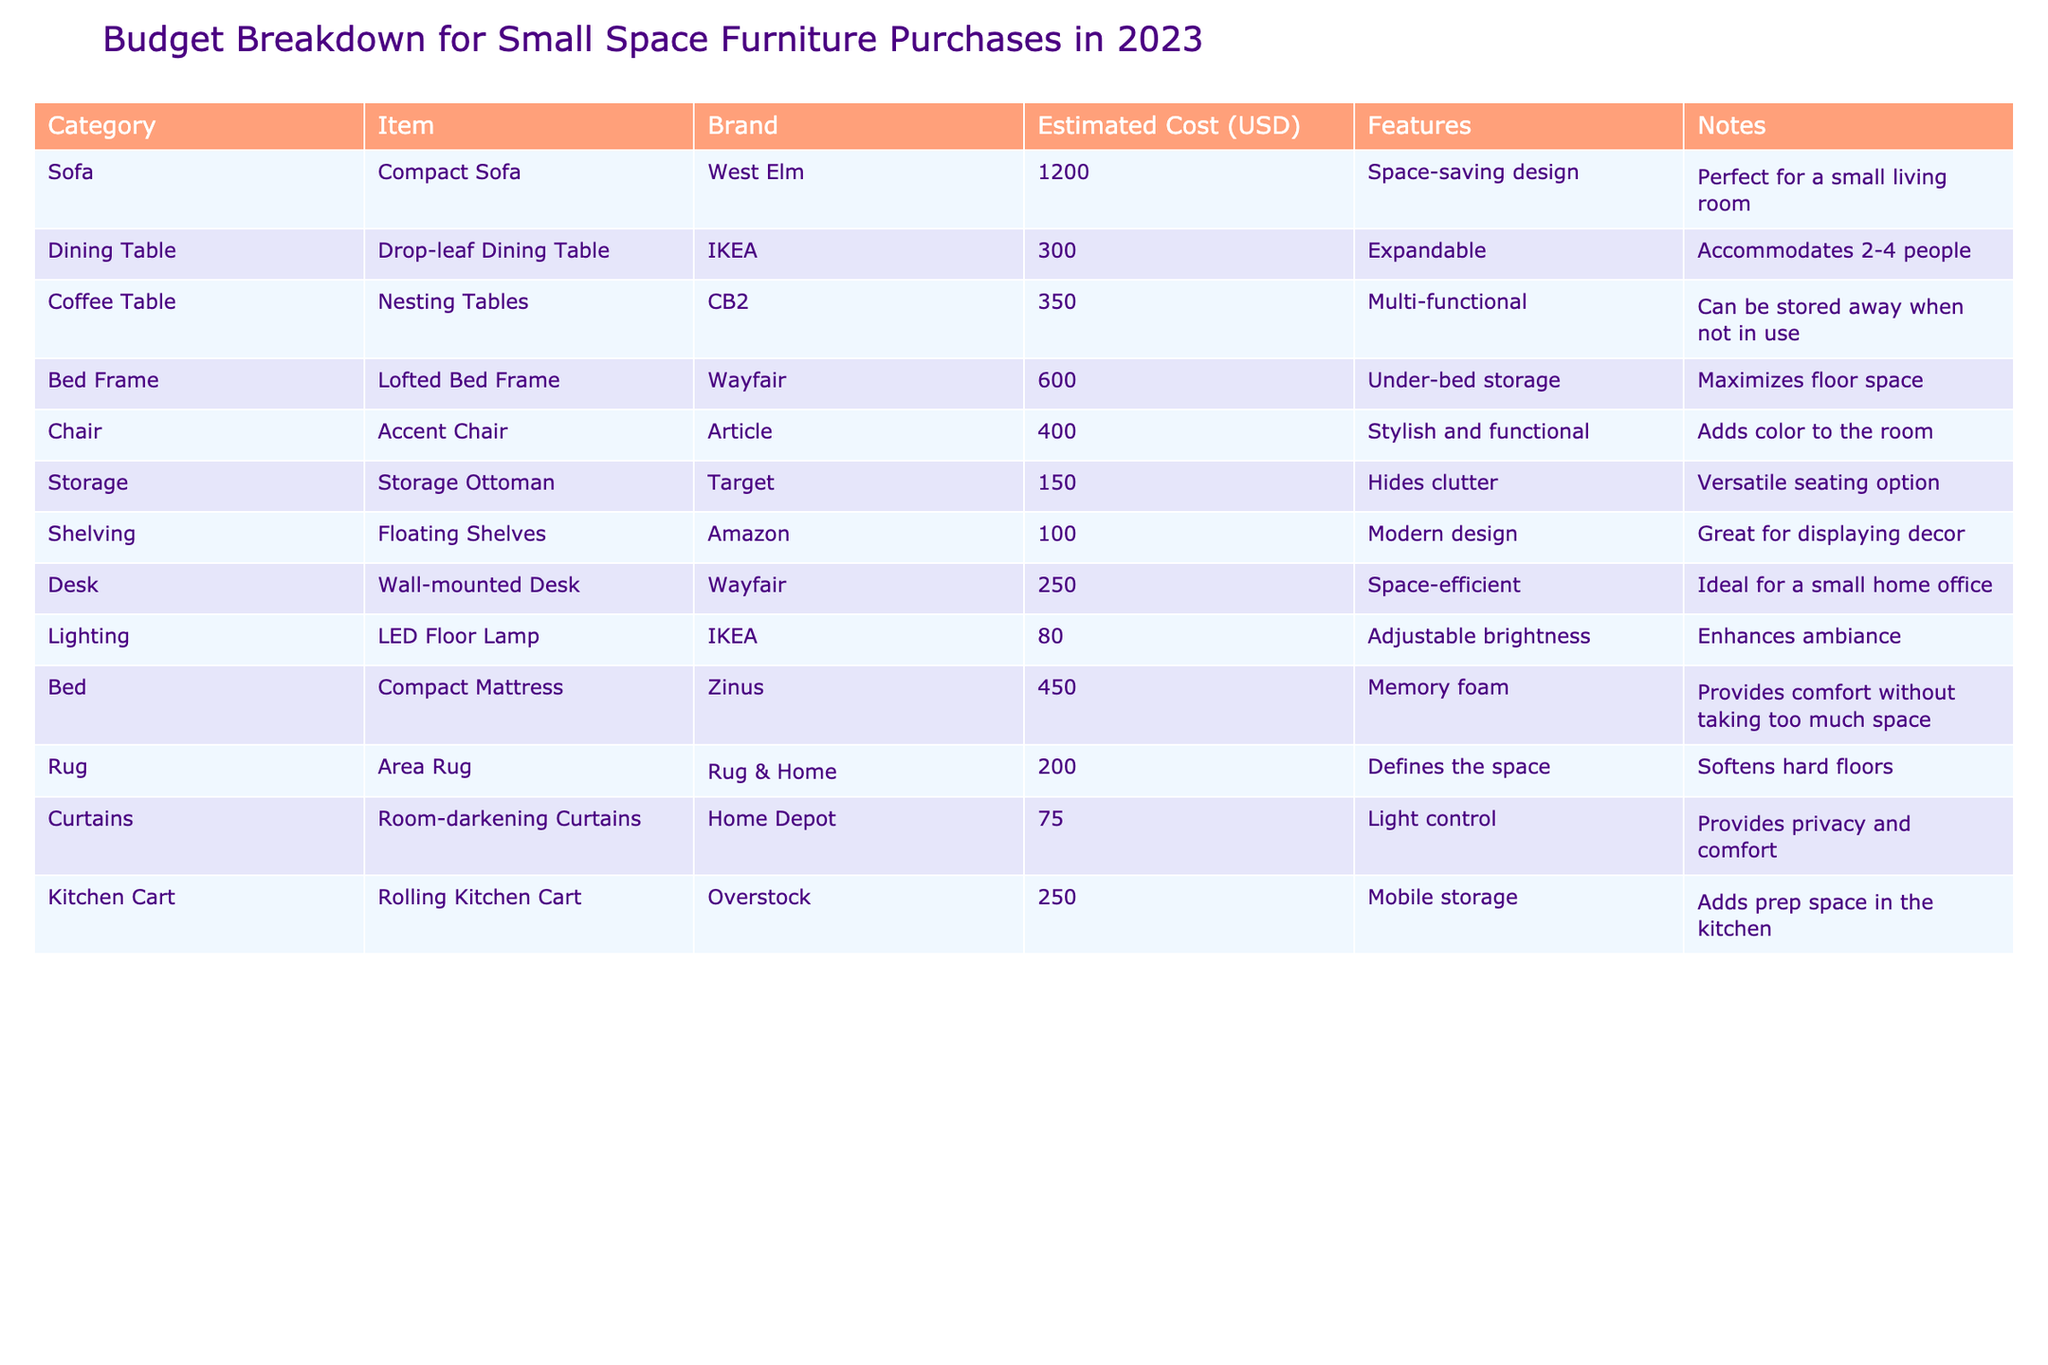What is the total estimated cost for all the furniture items listed? To find the total estimated cost, we add all the estimated costs together: 1200 + 300 + 350 + 600 + 400 + 150 + 100 + 250 + 80 + 450 + 200 + 75 + 250 = 4055
Answer: 4055 How much does the Accent Chair cost? The Accent Chair is listed under the Chair category with a cost of 400.
Answer: 400 Is the LED Floor Lamp the least expensive item on the list? The LED Floor Lamp is priced at 80, and when comparing it with all other items, it is the least expensive option listed.
Answer: Yes What is the average cost of all the storage solutions? The storage solutions in the table are the Storage Ottoman and the Lofted Bed Frame. Their costs are 150 and 600 respectively. To find the average, we calculate (150 + 600) / 2 = 375.
Answer: 375 Which item has the highest estimated cost? We evaluate all the estimated costs: 1200 (Sofa) is the highest when compared to the other items listed.
Answer: Compact Sofa, 1200 What is the combined cost of all dining and kitchen-related furniture items? The dining-related furniture consists of the Drop-leaf Dining Table (300) and the Rolling Kitchen Cart (250). Adding these gives us 300 + 250 = 550.
Answer: 550 What percentage of the total budget does the Compact Mattress represent? The Compact Mattress is priced at 450. First, we find the total estimated cost, which is 4055. Then, we calculate (450 / 4055) * 100 = 11.08%.
Answer: 11.08% Are all the items from different brands? Upon checking the table, it is noted that some items share brands (e.g., IKEA appears twice), indicating not all items are from different brands.
Answer: No What feature does the Wall-mounted Desk provide? The Wall-mounted Desk offers a space-efficient feature that makes it ideal for a small home office.
Answer: Space-efficient If we remove the most expensive item, what will the new total cost be? The most expensive item is the Compact Sofa at 1200. Subtracting this from the total cost of 4055 gives us 4055 - 1200 = 2855.
Answer: 2855 